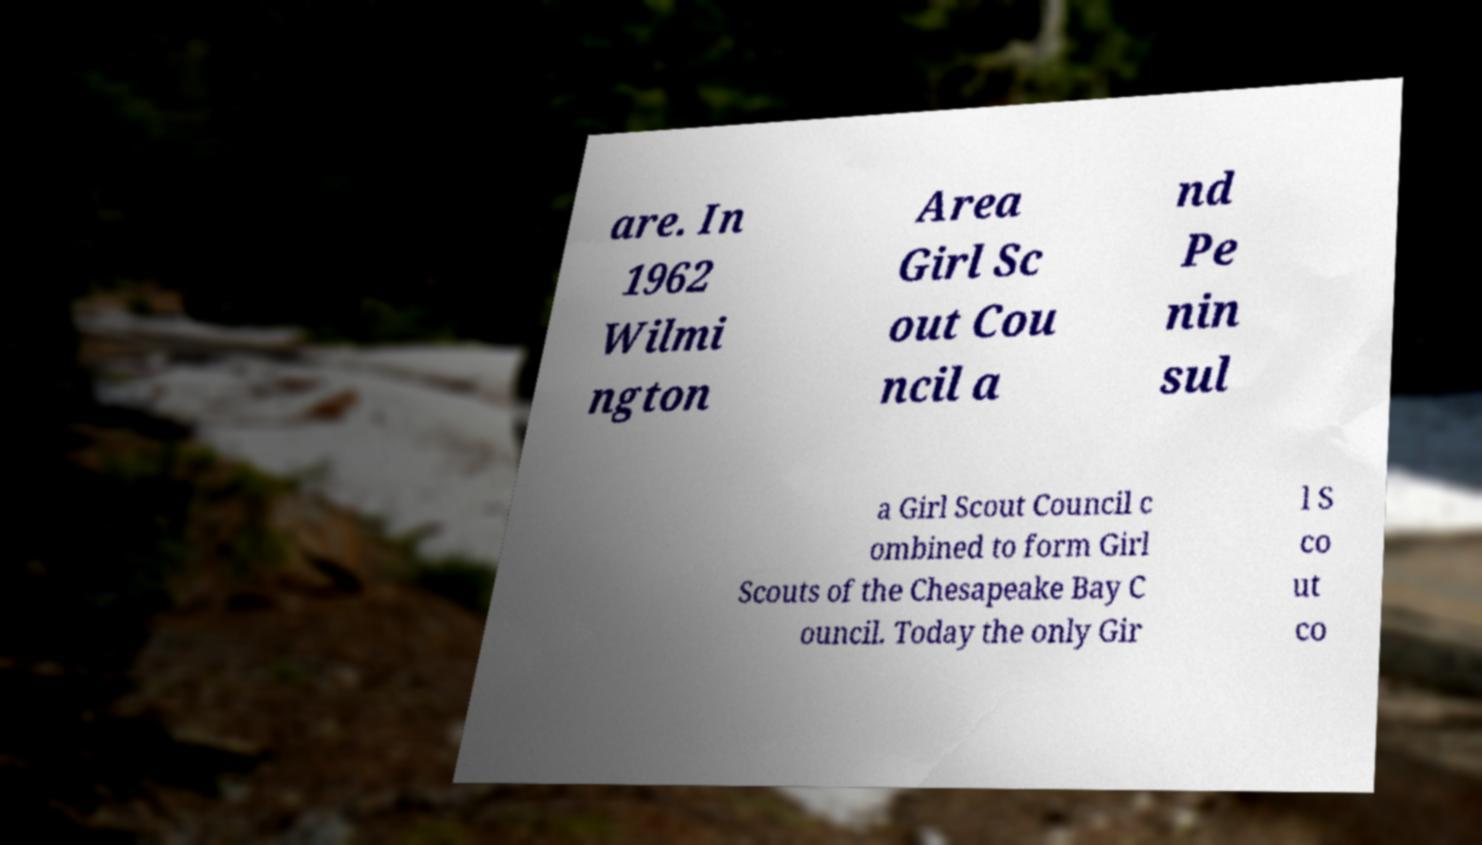Can you accurately transcribe the text from the provided image for me? are. In 1962 Wilmi ngton Area Girl Sc out Cou ncil a nd Pe nin sul a Girl Scout Council c ombined to form Girl Scouts of the Chesapeake Bay C ouncil. Today the only Gir l S co ut co 